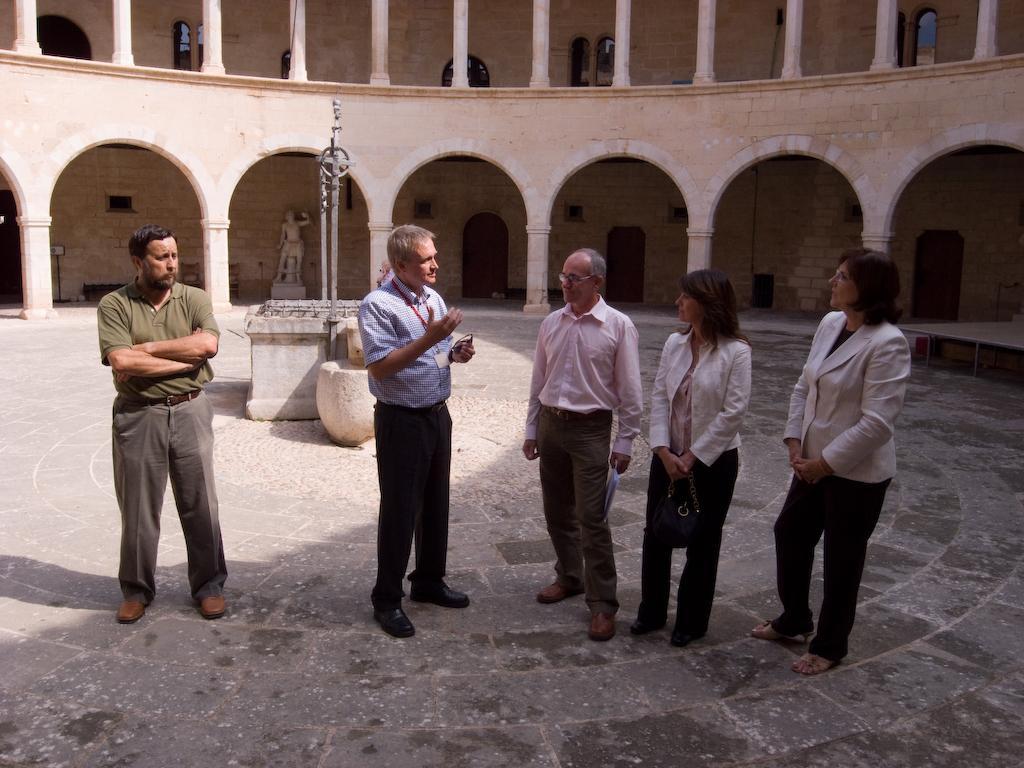How would you summarize this image in a sentence or two? In this image I can see the ground, number of persons are standing on the ground and few rock structures behind them. In the background I can see a building which is cream and white in color, a statue, few dollars and few doors of the building. 